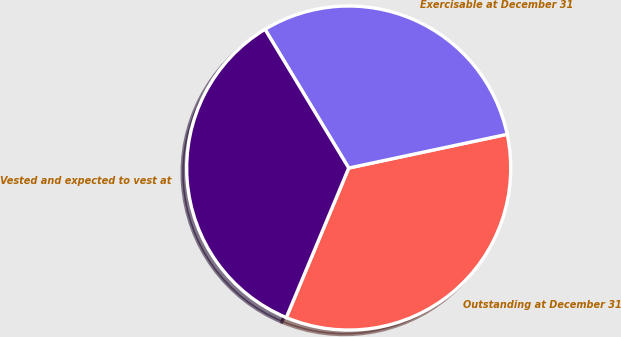<chart> <loc_0><loc_0><loc_500><loc_500><pie_chart><fcel>Outstanding at December 31<fcel>Exercisable at December 31<fcel>Vested and expected to vest at<nl><fcel>34.63%<fcel>30.3%<fcel>35.06%<nl></chart> 